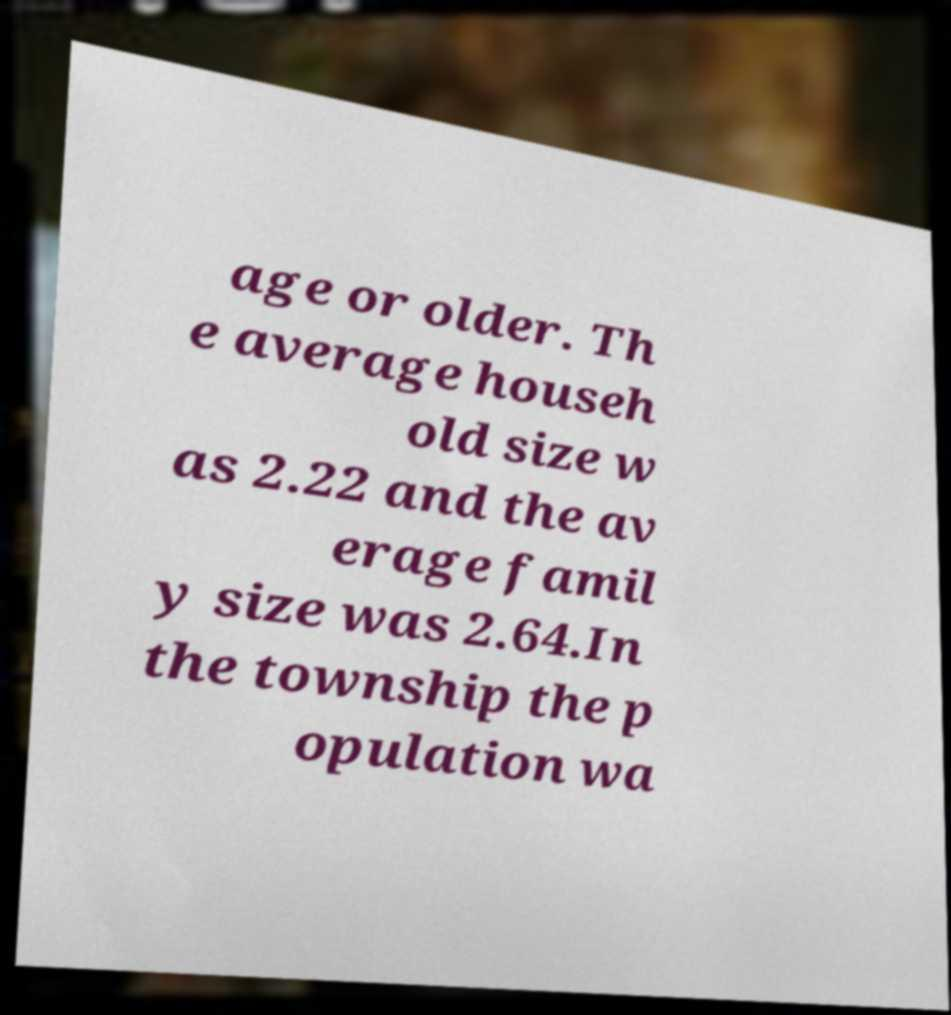Could you extract and type out the text from this image? age or older. Th e average househ old size w as 2.22 and the av erage famil y size was 2.64.In the township the p opulation wa 